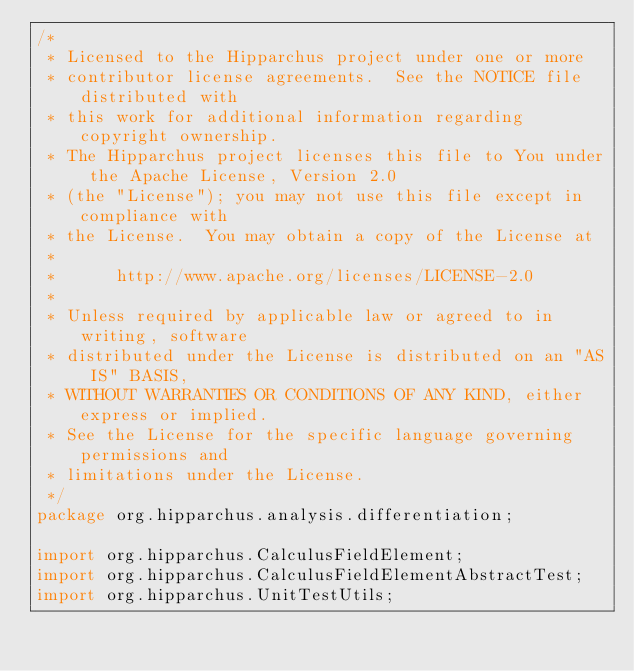Convert code to text. <code><loc_0><loc_0><loc_500><loc_500><_Java_>/*
 * Licensed to the Hipparchus project under one or more
 * contributor license agreements.  See the NOTICE file distributed with
 * this work for additional information regarding copyright ownership.
 * The Hipparchus project licenses this file to You under the Apache License, Version 2.0
 * (the "License"); you may not use this file except in compliance with
 * the License.  You may obtain a copy of the License at
 *
 *      http://www.apache.org/licenses/LICENSE-2.0
 *
 * Unless required by applicable law or agreed to in writing, software
 * distributed under the License is distributed on an "AS IS" BASIS,
 * WITHOUT WARRANTIES OR CONDITIONS OF ANY KIND, either express or implied.
 * See the License for the specific language governing permissions and
 * limitations under the License.
 */
package org.hipparchus.analysis.differentiation;

import org.hipparchus.CalculusFieldElement;
import org.hipparchus.CalculusFieldElementAbstractTest;
import org.hipparchus.UnitTestUtils;</code> 